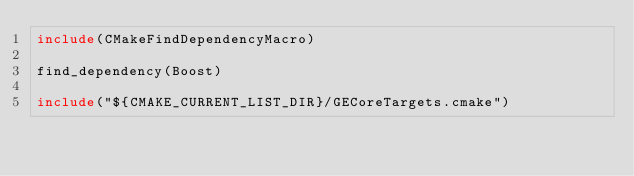Convert code to text. <code><loc_0><loc_0><loc_500><loc_500><_CMake_>include(CMakeFindDependencyMacro)

find_dependency(Boost)

include("${CMAKE_CURRENT_LIST_DIR}/GECoreTargets.cmake")</code> 